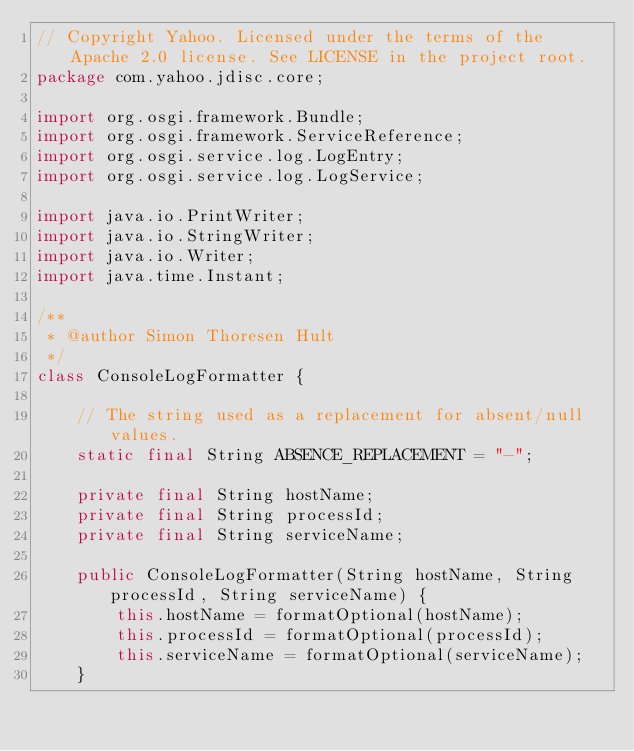<code> <loc_0><loc_0><loc_500><loc_500><_Java_>// Copyright Yahoo. Licensed under the terms of the Apache 2.0 license. See LICENSE in the project root.
package com.yahoo.jdisc.core;

import org.osgi.framework.Bundle;
import org.osgi.framework.ServiceReference;
import org.osgi.service.log.LogEntry;
import org.osgi.service.log.LogService;

import java.io.PrintWriter;
import java.io.StringWriter;
import java.io.Writer;
import java.time.Instant;

/**
 * @author Simon Thoresen Hult
 */
class ConsoleLogFormatter {

    // The string used as a replacement for absent/null values.
    static final String ABSENCE_REPLACEMENT = "-";

    private final String hostName;
    private final String processId;
    private final String serviceName;

    public ConsoleLogFormatter(String hostName, String processId, String serviceName) {
        this.hostName = formatOptional(hostName);
        this.processId = formatOptional(processId);
        this.serviceName = formatOptional(serviceName);
    }
</code> 